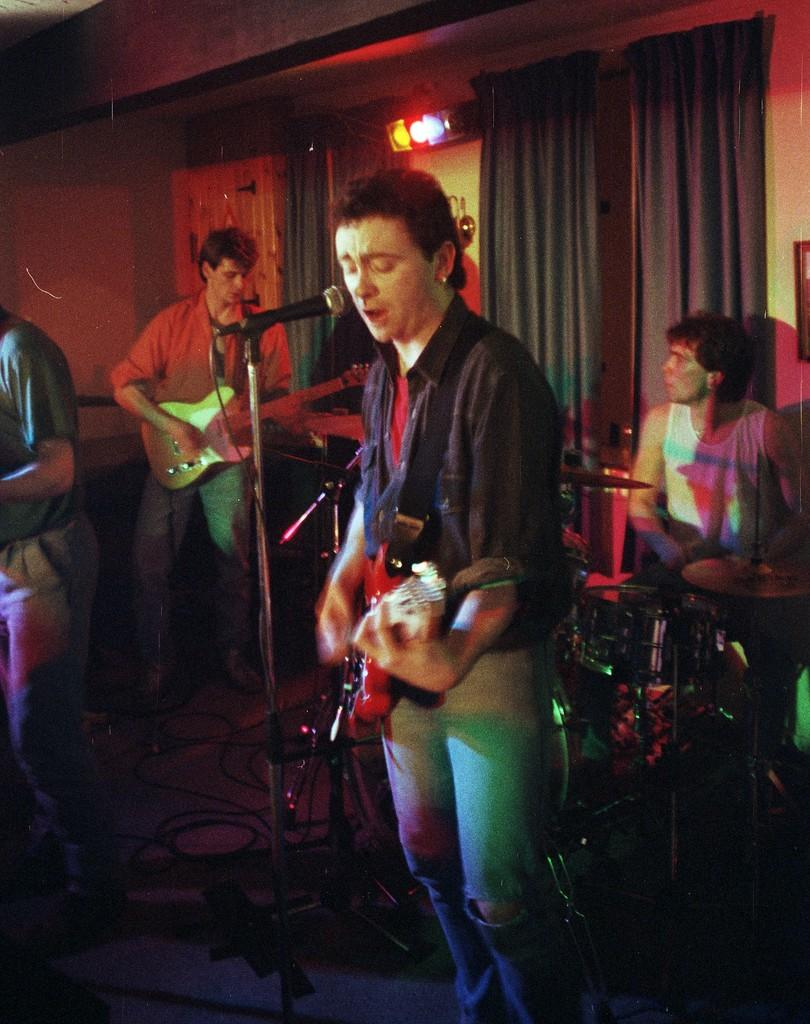How many people are in the image? There are three people in the image. What are the two men standing doing? The two men standing are playing guitar and singing. What object is present in the image that is commonly used for amplifying sound? A microphone is present in the image. What is the seated man doing in the image? The seated man is playing drums. What type of soup is being served in the image? There is no soup present in the image. Can you see any railway tracks in the image? There are no railway tracks visible in the image. 